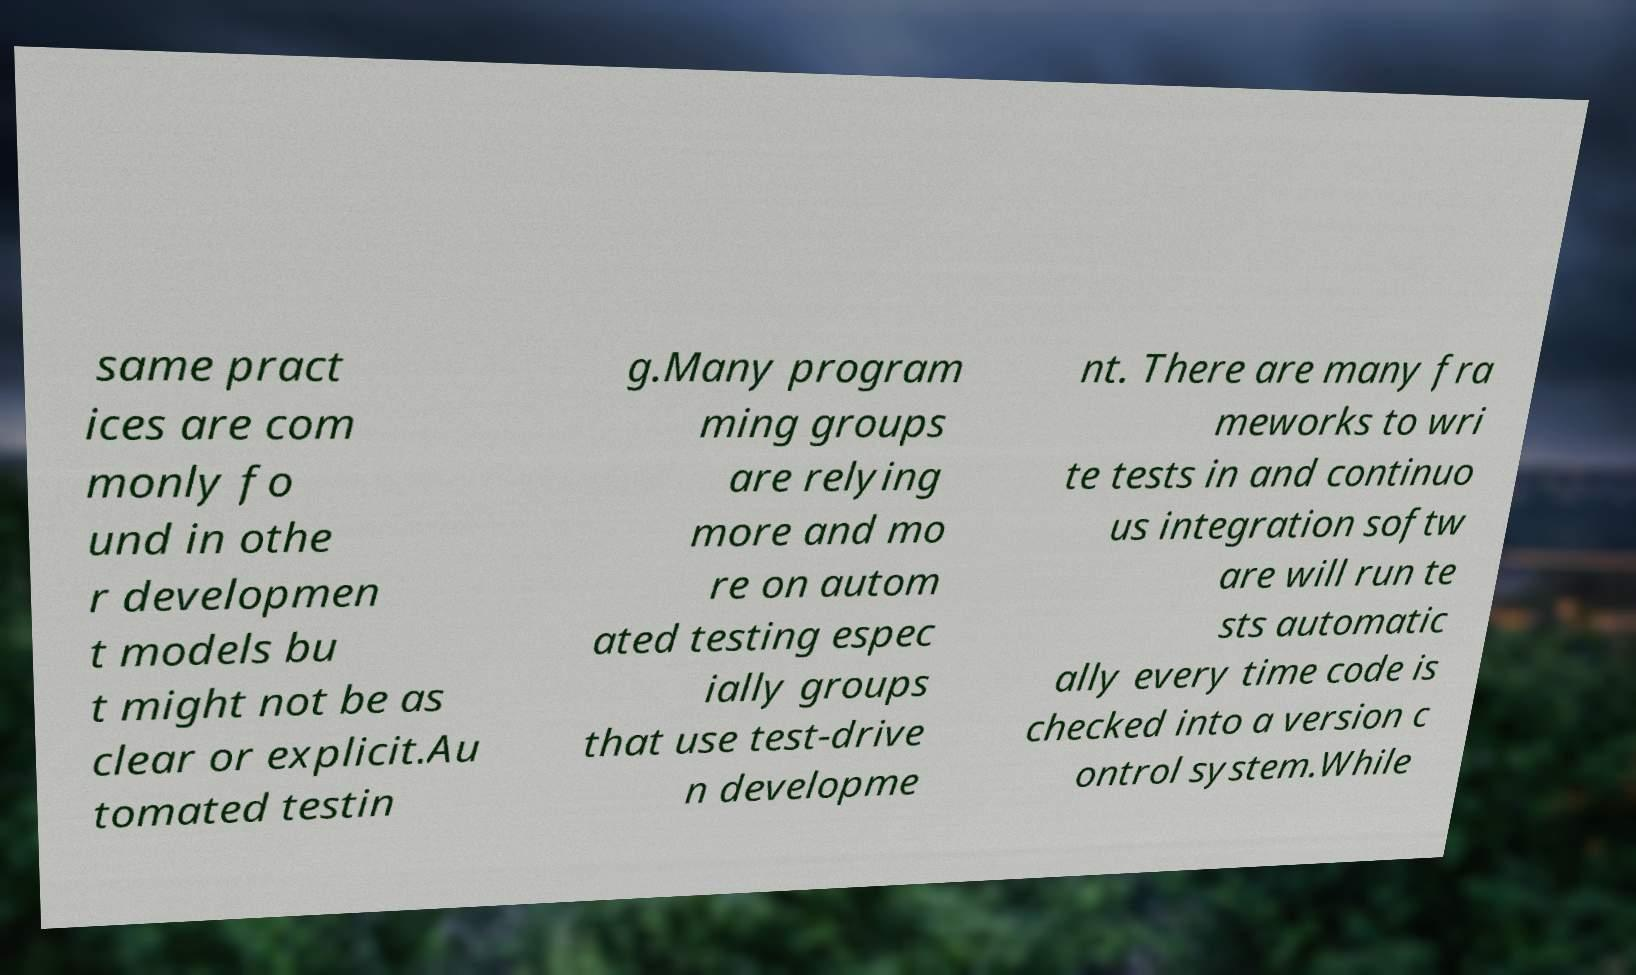Please identify and transcribe the text found in this image. same pract ices are com monly fo und in othe r developmen t models bu t might not be as clear or explicit.Au tomated testin g.Many program ming groups are relying more and mo re on autom ated testing espec ially groups that use test-drive n developme nt. There are many fra meworks to wri te tests in and continuo us integration softw are will run te sts automatic ally every time code is checked into a version c ontrol system.While 